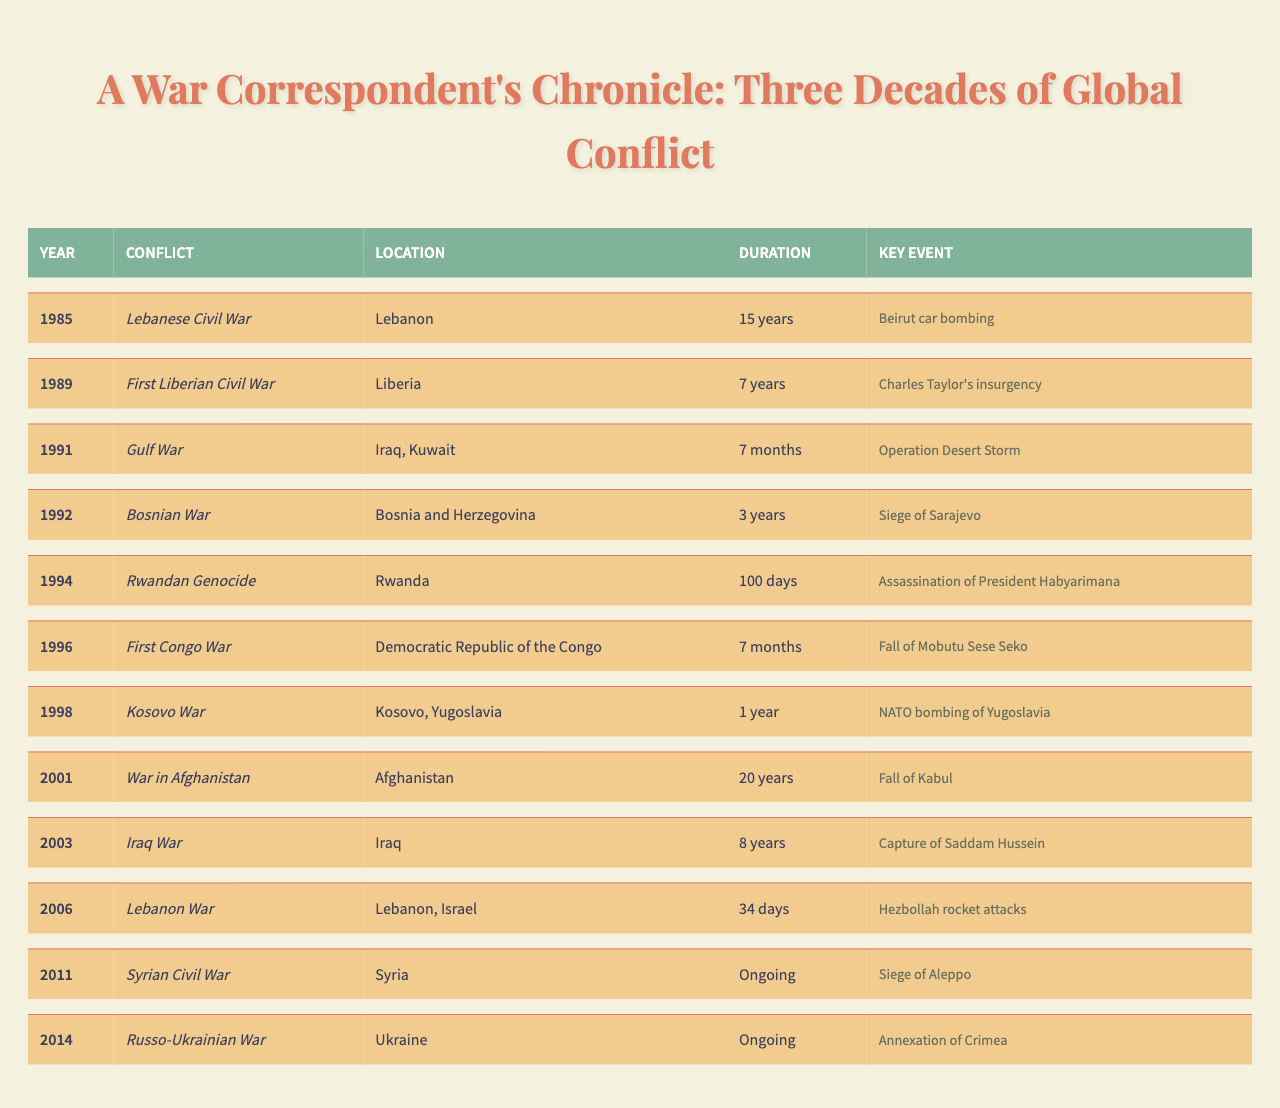What year did the Rwandan Genocide occur? The Rwandan Genocide is listed in the table under the year 1994.
Answer: 1994 Which conflict lasted the longest according to the table? The table shows that the War in Afghanistan lasted for 20 years, making it the longest conflict listed.
Answer: War in Afghanistan How many conflicts took place in the 1990s? The table lists six conflicts that occurred in the 1990s: Lebanese Civil War, First Liberian Civil War, Gulf War, Bosnian War, Rwandan Genocide, and First Congo War.
Answer: 6 What is the key event associated with the Gulf War? The table indicates that the key event for the Gulf War is "Operation Desert Storm."
Answer: Operation Desert Storm Which conflict had the shortest duration recorded? According to the table, the Rwandan Genocide lasted for 100 days, making it the shortest duration of the conflicts listed.
Answer: Rwandan Genocide Is the Syrian Civil War ongoing? The table specifies that the Syrian Civil War is labeled as "Ongoing," which confirms that this conflict has not concluded.
Answer: Yes How many years did the First Liberian Civil War last compared to the Kosovo War? The First Liberian Civil War lasted 7 years, while the Kosovo War lasted 1 year, making the Liberian conflict longer by 6 years.
Answer: 6 years Which two conflicts involved Lebanon, and what were their key events? The table lists the Lebanese Civil War with the key event being the Beirut car bombing, and the Lebanon War with Hezbollah rocket attacks as the key event.
Answer: Lebanese Civil War (Beirut car bombing), Lebanon War (Hezbollah rocket attacks) In what year did the Siege of Aleppo occur, and which conflict was it part of? The Siege of Aleppo occurred during the Syrian Civil War, which began in 2011. The table indicates that 2011 is the year for this conflict.
Answer: 2011 Calculate the total duration of conflicts listed in the 1980s and 1990s combined. The Lebanese Civil War lasted 15 years (1985), the First Liberian Civil War lasted 7 years (1989), meaning their total duration is 15 + 7 = 22 years.
Answer: 22 years 